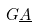<formula> <loc_0><loc_0><loc_500><loc_500>G \underline { A }</formula> 